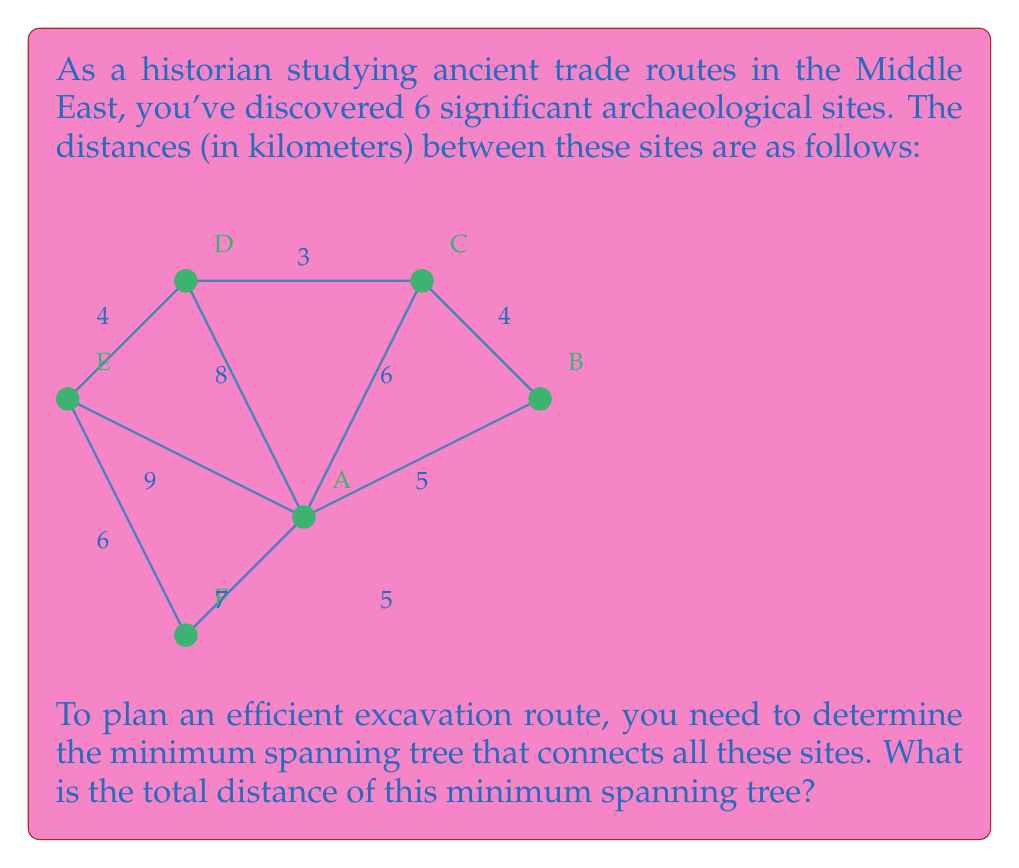Provide a solution to this math problem. To find the minimum spanning tree, we can use Kruskal's algorithm:

1) First, sort all edges by weight (distance) in ascending order:
   C-D: 3
   B-C: 4
   D-E: 4
   A-B: 5
   B-F: 5
   A-C: 6
   E-F: 6
   A-F: 7
   A-D: 8
   A-E: 9

2) Start with an empty graph and add edges in this order, skipping any that would create a cycle:

   - Add C-D (3)
   - Add B-C (4)
   - Add D-E (4)
   - Add A-B (5)
   - Skip B-F (would create cycle)
   - Skip A-C (would create cycle)
   - Add E-F (6)

3) We now have 5 edges, which is correct for a minimum spanning tree of 6 vertices (n-1 edges where n is the number of vertices).

4) The edges in our minimum spanning tree are:
   C-D (3), B-C (4), D-E (4), A-B (5), E-F (6)

5) Sum the distances: $3 + 4 + 4 + 5 + 6 = 22$

Therefore, the total distance of the minimum spanning tree is 22 kilometers.
Answer: 22 km 